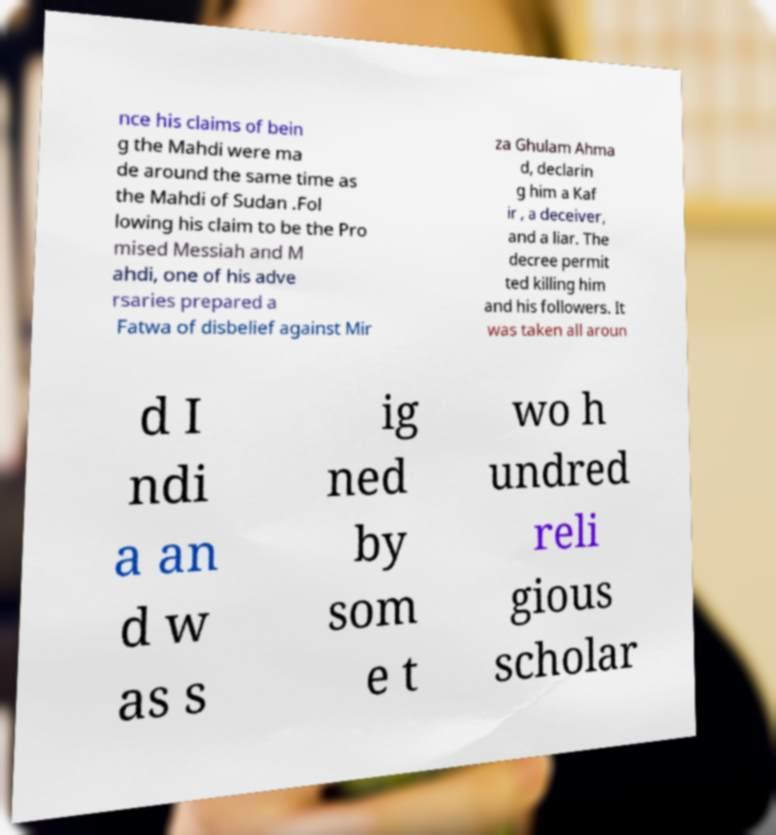I need the written content from this picture converted into text. Can you do that? nce his claims of bein g the Mahdi were ma de around the same time as the Mahdi of Sudan .Fol lowing his claim to be the Pro mised Messiah and M ahdi, one of his adve rsaries prepared a Fatwa of disbelief against Mir za Ghulam Ahma d, declarin g him a Kaf ir , a deceiver, and a liar. The decree permit ted killing him and his followers. It was taken all aroun d I ndi a an d w as s ig ned by som e t wo h undred reli gious scholar 